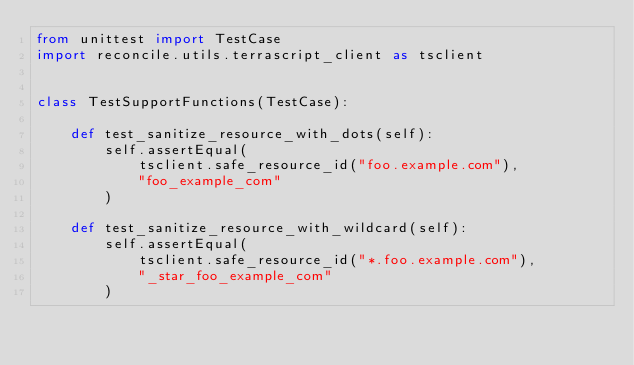<code> <loc_0><loc_0><loc_500><loc_500><_Python_>from unittest import TestCase
import reconcile.utils.terrascript_client as tsclient


class TestSupportFunctions(TestCase):

    def test_sanitize_resource_with_dots(self):
        self.assertEqual(
            tsclient.safe_resource_id("foo.example.com"),
            "foo_example_com"
        )

    def test_sanitize_resource_with_wildcard(self):
        self.assertEqual(
            tsclient.safe_resource_id("*.foo.example.com"),
            "_star_foo_example_com"
        )
</code> 